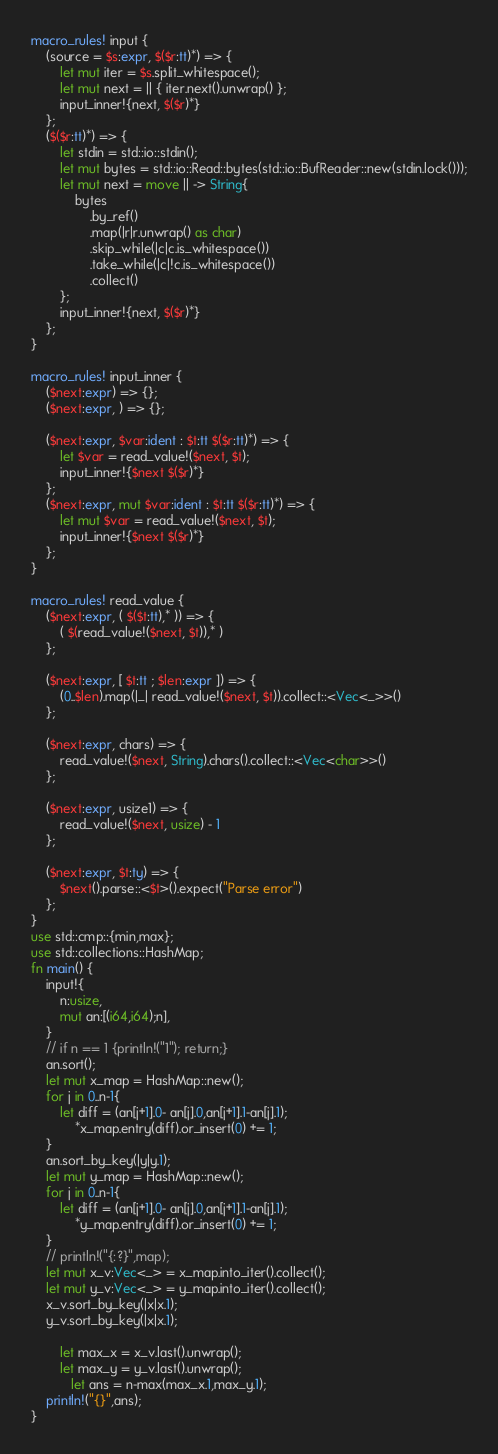Convert code to text. <code><loc_0><loc_0><loc_500><loc_500><_Rust_>macro_rules! input {
    (source = $s:expr, $($r:tt)*) => {
        let mut iter = $s.split_whitespace();
        let mut next = || { iter.next().unwrap() };
        input_inner!{next, $($r)*}
    };
    ($($r:tt)*) => {
        let stdin = std::io::stdin();
        let mut bytes = std::io::Read::bytes(std::io::BufReader::new(stdin.lock()));
        let mut next = move || -> String{
            bytes
                .by_ref()
                .map(|r|r.unwrap() as char)
                .skip_while(|c|c.is_whitespace())
                .take_while(|c|!c.is_whitespace())
                .collect()
        };
        input_inner!{next, $($r)*}
    };
}

macro_rules! input_inner {
    ($next:expr) => {};
    ($next:expr, ) => {};

    ($next:expr, $var:ident : $t:tt $($r:tt)*) => {
        let $var = read_value!($next, $t);
        input_inner!{$next $($r)*}
    };
    ($next:expr, mut $var:ident : $t:tt $($r:tt)*) => {
        let mut $var = read_value!($next, $t);
        input_inner!{$next $($r)*}
    };
}

macro_rules! read_value {
    ($next:expr, ( $($t:tt),* )) => {
        ( $(read_value!($next, $t)),* )
    };

    ($next:expr, [ $t:tt ; $len:expr ]) => {
        (0..$len).map(|_| read_value!($next, $t)).collect::<Vec<_>>()
    };

    ($next:expr, chars) => {
        read_value!($next, String).chars().collect::<Vec<char>>()
    };

    ($next:expr, usize1) => {
        read_value!($next, usize) - 1
    };

    ($next:expr, $t:ty) => {
        $next().parse::<$t>().expect("Parse error")
    };
}
use std::cmp::{min,max};
use std::collections::HashMap;
fn main() {
    input!{
        n:usize,
        mut an:[(i64,i64);n],
    }
    // if n == 1 {println!("1"); return;}
    an.sort();
    let mut x_map = HashMap::new();
    for j in 0..n-1{
        let diff = (an[j+1].0- an[j].0,an[j+1].1-an[j].1);  
            *x_map.entry(diff).or_insert(0) += 1;
    }
    an.sort_by_key(|y|y.1);
    let mut y_map = HashMap::new();
    for j in 0..n-1{
        let diff = (an[j+1].0- an[j].0,an[j+1].1-an[j].1);
            *y_map.entry(diff).or_insert(0) += 1;
    }
    // println!("{:?}",map);
    let mut x_v:Vec<_> = x_map.into_iter().collect();
    let mut y_v:Vec<_> = y_map.into_iter().collect();
    x_v.sort_by_key(|x|x.1);
    y_v.sort_by_key(|x|x.1);

        let max_x = x_v.last().unwrap();
        let max_y = y_v.last().unwrap();
           let ans = n-max(max_x.1,max_y.1);
    println!("{}",ans);
}</code> 